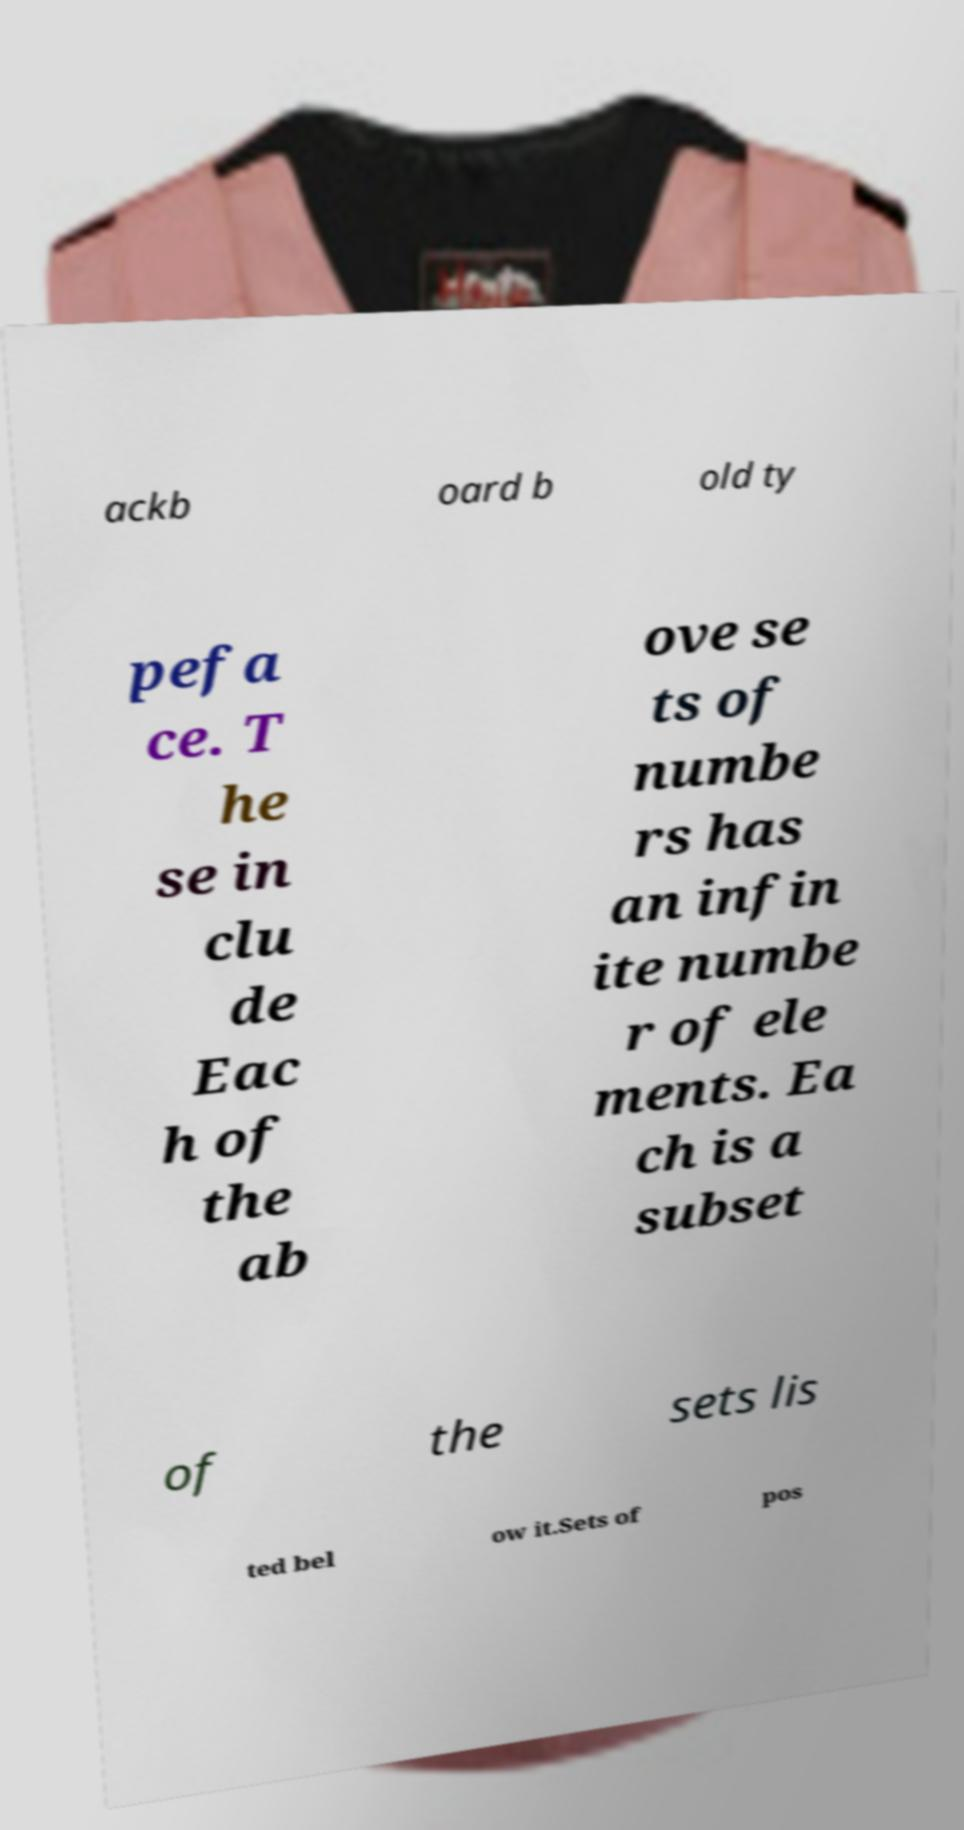Can you read and provide the text displayed in the image?This photo seems to have some interesting text. Can you extract and type it out for me? ackb oard b old ty pefa ce. T he se in clu de Eac h of the ab ove se ts of numbe rs has an infin ite numbe r of ele ments. Ea ch is a subset of the sets lis ted bel ow it.Sets of pos 